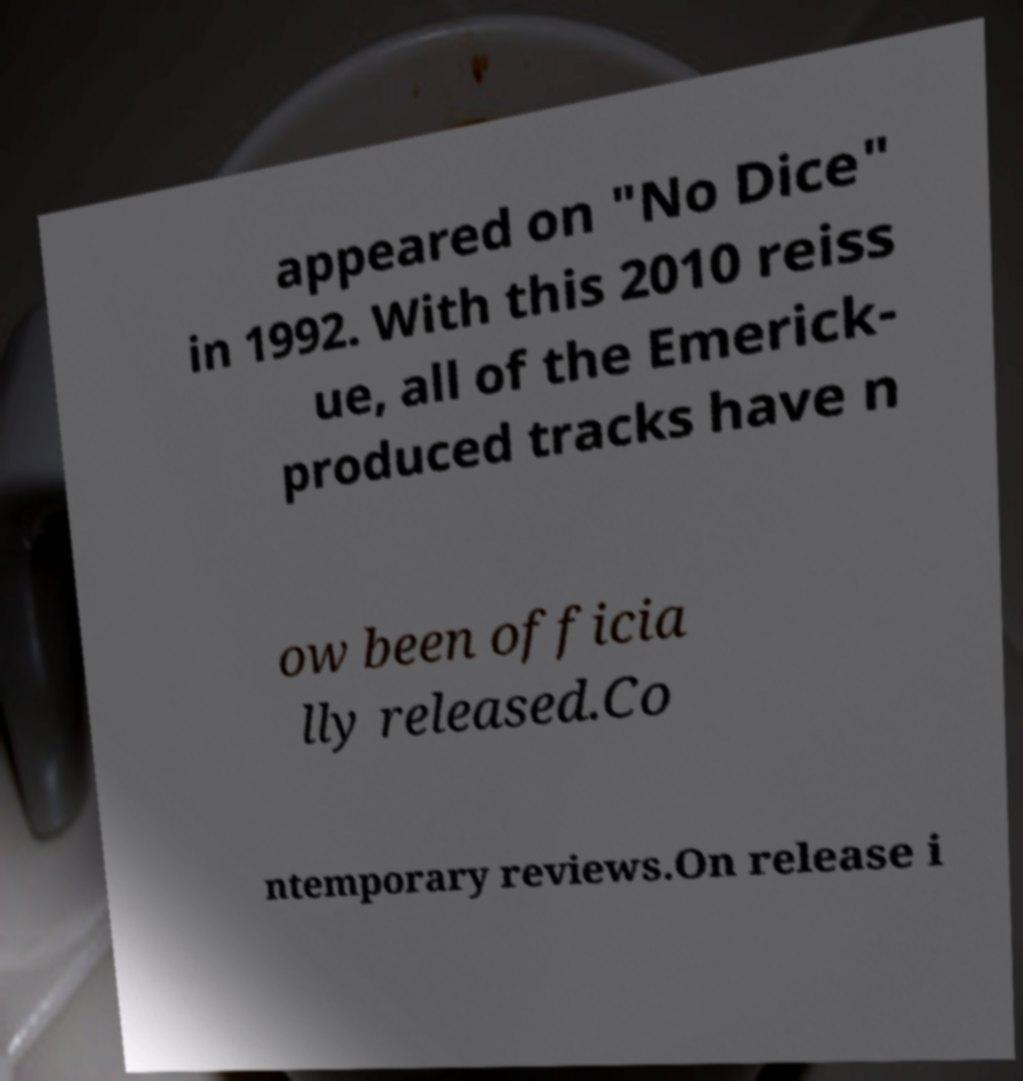I need the written content from this picture converted into text. Can you do that? appeared on "No Dice" in 1992. With this 2010 reiss ue, all of the Emerick- produced tracks have n ow been officia lly released.Co ntemporary reviews.On release i 